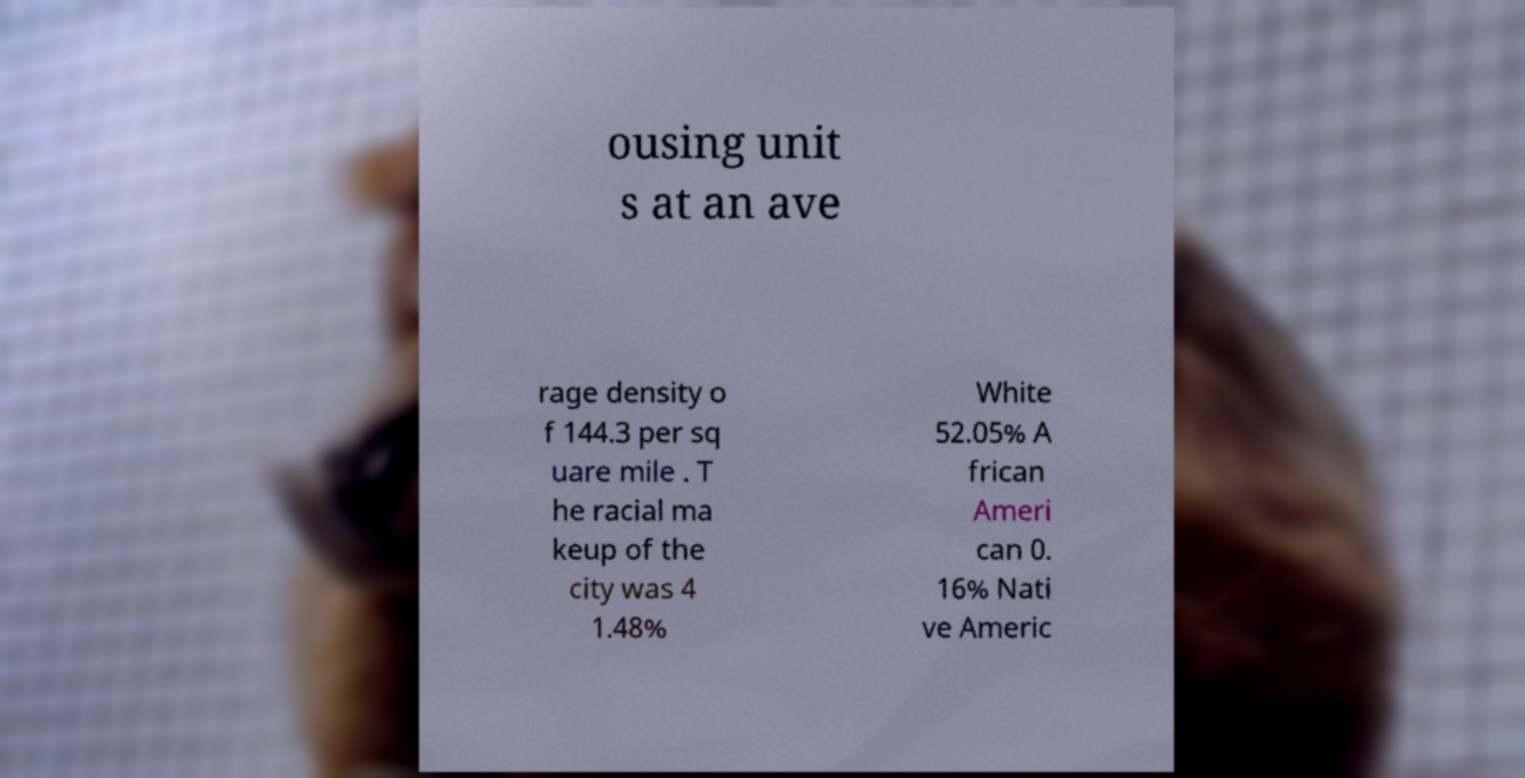Please identify and transcribe the text found in this image. ousing unit s at an ave rage density o f 144.3 per sq uare mile . T he racial ma keup of the city was 4 1.48% White 52.05% A frican Ameri can 0. 16% Nati ve Americ 